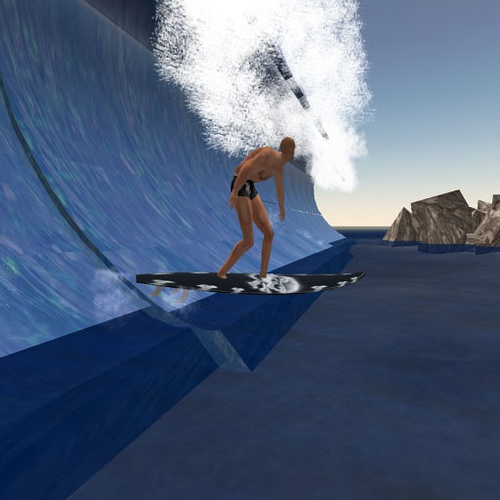Describe the objects in this image and their specific colors. I can see people in darkblue, maroon, gray, and brown tones and surfboard in darkblue, black, darkgray, gray, and navy tones in this image. 